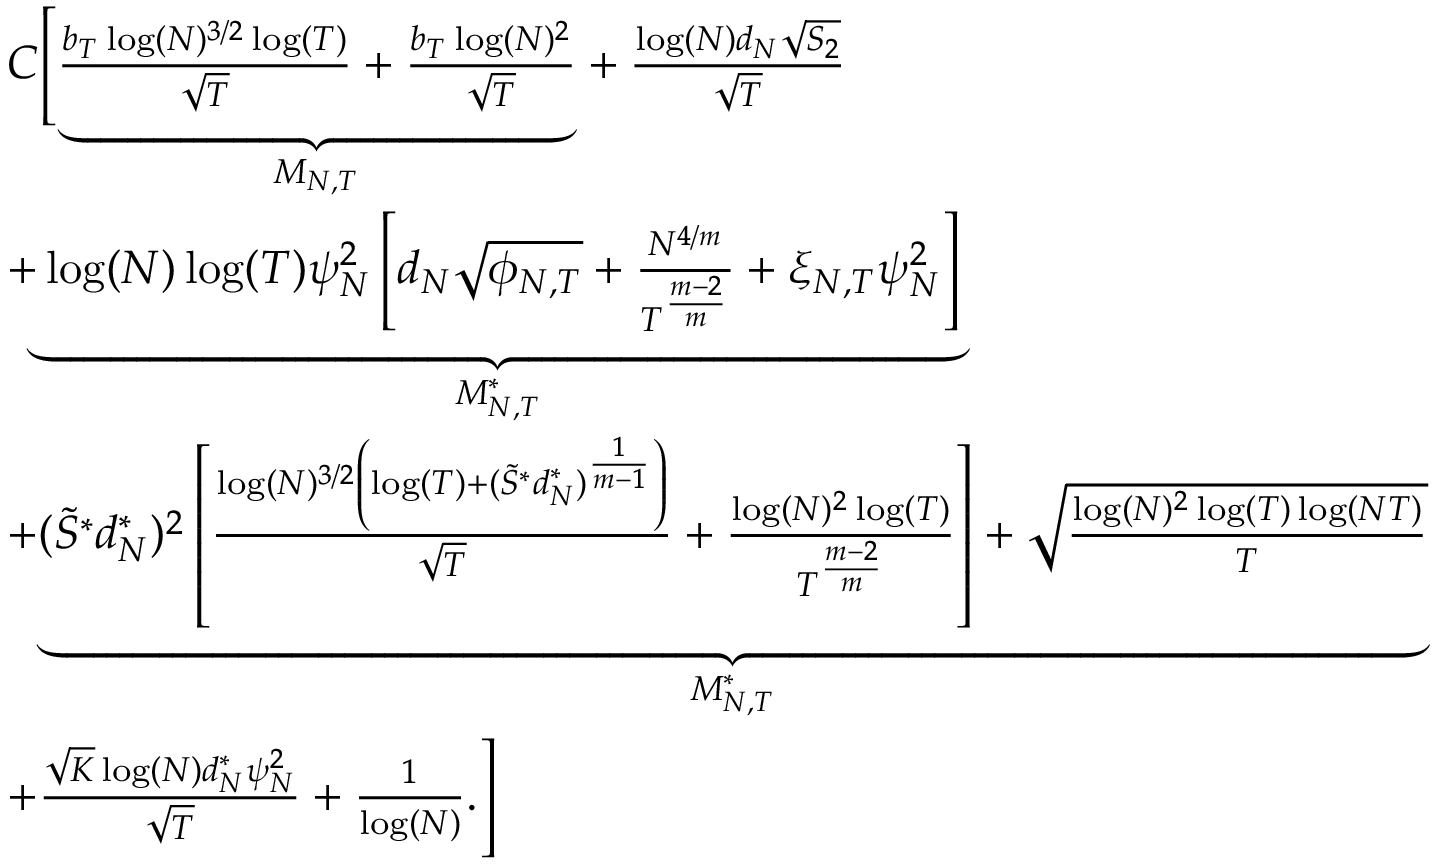<formula> <loc_0><loc_0><loc_500><loc_500>\begin{array} { r l } & { C \left [ \underset { { M _ { N , T } } } { \underbrace { \frac { b _ { T } \log ( N ) ^ { 3 / 2 } \log ( T ) } { \sqrt { T } } + \frac { b _ { T } \log ( N ) ^ { 2 } } { \sqrt { T } } } } + \frac { \log ( N ) d _ { N } \sqrt { S _ { 2 } } } { \sqrt { T } } } \\ & { + \underset { { M _ { N , T } ^ { * } } } { \underbrace { \log ( N ) \log ( T ) \psi _ { N } ^ { 2 } \left [ d _ { N } \sqrt { \phi _ { N , T } } + \frac { N ^ { 4 / m } } { T ^ { \frac { m - 2 } { m } } } + \xi _ { N , T } \psi _ { N } ^ { 2 } \right ] } } } \\ & { + \underset { { M _ { N , T } ^ { * } } } { \underbrace { ( \tilde { S } ^ { * } d _ { N } ^ { * } ) ^ { 2 } \left [ \frac { \log ( N ) ^ { 3 / 2 } \left ( \log ( T ) + ( \tilde { S } ^ { * } d _ { N } ^ { * } ) ^ { \frac { 1 } { m - 1 } } \right ) } { \sqrt { T } } + \frac { \log ( N ) ^ { 2 } \log ( T ) } { T ^ { \frac { m - 2 } { m } } } \right ] + \sqrt { \frac { \log ( N ) ^ { 2 } \log ( T ) \log ( N T ) } { T } } } } } \\ & { + \frac { \sqrt { K } \log ( N ) d _ { N } ^ { * } \psi _ { N } ^ { 2 } } { \sqrt { T } } + \frac { 1 } { \log ( N ) } . \right ] } \end{array}</formula> 